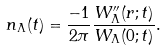<formula> <loc_0><loc_0><loc_500><loc_500>n _ { \Lambda } ( t ) = \frac { - 1 } { 2 \pi } \frac { W ^ { \prime \prime } _ { \Lambda } ( r ; t ) } { W _ { \Lambda } ( 0 ; t ) } .</formula> 